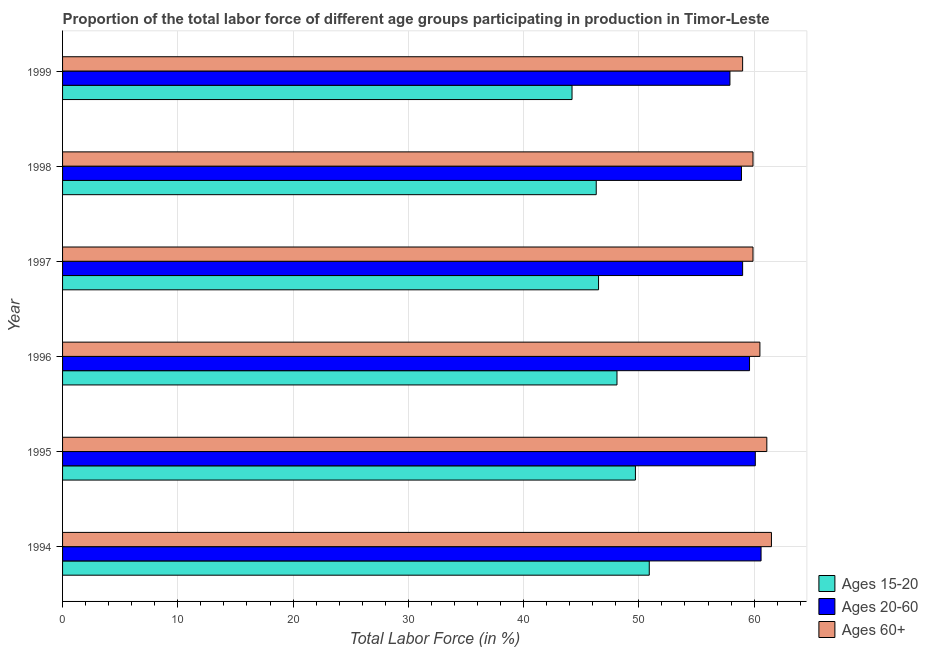Are the number of bars per tick equal to the number of legend labels?
Keep it short and to the point. Yes. Are the number of bars on each tick of the Y-axis equal?
Give a very brief answer. Yes. How many bars are there on the 3rd tick from the bottom?
Offer a terse response. 3. What is the label of the 5th group of bars from the top?
Ensure brevity in your answer.  1995. In how many cases, is the number of bars for a given year not equal to the number of legend labels?
Ensure brevity in your answer.  0. What is the percentage of labor force above age 60 in 1998?
Ensure brevity in your answer.  59.9. Across all years, what is the maximum percentage of labor force within the age group 15-20?
Ensure brevity in your answer.  50.9. Across all years, what is the minimum percentage of labor force within the age group 15-20?
Give a very brief answer. 44.2. In which year was the percentage of labor force above age 60 maximum?
Offer a terse response. 1994. In which year was the percentage of labor force above age 60 minimum?
Provide a short and direct response. 1999. What is the total percentage of labor force within the age group 15-20 in the graph?
Offer a very short reply. 285.7. What is the difference between the percentage of labor force above age 60 in 1994 and the percentage of labor force within the age group 20-60 in 1999?
Offer a terse response. 3.6. What is the average percentage of labor force within the age group 15-20 per year?
Offer a very short reply. 47.62. In how many years, is the percentage of labor force above age 60 greater than 2 %?
Your answer should be very brief. 6. Is the difference between the percentage of labor force within the age group 20-60 in 1994 and 1999 greater than the difference between the percentage of labor force within the age group 15-20 in 1994 and 1999?
Ensure brevity in your answer.  No. What is the difference between the highest and the second highest percentage of labor force above age 60?
Your answer should be very brief. 0.4. What is the difference between the highest and the lowest percentage of labor force above age 60?
Your answer should be compact. 2.5. What does the 2nd bar from the top in 1995 represents?
Provide a succinct answer. Ages 20-60. What does the 3rd bar from the bottom in 1997 represents?
Offer a very short reply. Ages 60+. Does the graph contain grids?
Offer a very short reply. Yes. Where does the legend appear in the graph?
Offer a very short reply. Bottom right. How many legend labels are there?
Provide a succinct answer. 3. How are the legend labels stacked?
Keep it short and to the point. Vertical. What is the title of the graph?
Offer a very short reply. Proportion of the total labor force of different age groups participating in production in Timor-Leste. Does "Male employers" appear as one of the legend labels in the graph?
Make the answer very short. No. What is the label or title of the X-axis?
Offer a very short reply. Total Labor Force (in %). What is the label or title of the Y-axis?
Make the answer very short. Year. What is the Total Labor Force (in %) in Ages 15-20 in 1994?
Offer a terse response. 50.9. What is the Total Labor Force (in %) of Ages 20-60 in 1994?
Provide a short and direct response. 60.6. What is the Total Labor Force (in %) of Ages 60+ in 1994?
Your response must be concise. 61.5. What is the Total Labor Force (in %) in Ages 15-20 in 1995?
Offer a very short reply. 49.7. What is the Total Labor Force (in %) of Ages 20-60 in 1995?
Provide a succinct answer. 60.1. What is the Total Labor Force (in %) in Ages 60+ in 1995?
Your answer should be very brief. 61.1. What is the Total Labor Force (in %) of Ages 15-20 in 1996?
Provide a short and direct response. 48.1. What is the Total Labor Force (in %) of Ages 20-60 in 1996?
Offer a terse response. 59.6. What is the Total Labor Force (in %) of Ages 60+ in 1996?
Your response must be concise. 60.5. What is the Total Labor Force (in %) in Ages 15-20 in 1997?
Your answer should be compact. 46.5. What is the Total Labor Force (in %) in Ages 20-60 in 1997?
Ensure brevity in your answer.  59. What is the Total Labor Force (in %) in Ages 60+ in 1997?
Your answer should be compact. 59.9. What is the Total Labor Force (in %) in Ages 15-20 in 1998?
Your response must be concise. 46.3. What is the Total Labor Force (in %) in Ages 20-60 in 1998?
Keep it short and to the point. 58.9. What is the Total Labor Force (in %) in Ages 60+ in 1998?
Provide a short and direct response. 59.9. What is the Total Labor Force (in %) of Ages 15-20 in 1999?
Offer a terse response. 44.2. What is the Total Labor Force (in %) of Ages 20-60 in 1999?
Provide a short and direct response. 57.9. What is the Total Labor Force (in %) of Ages 60+ in 1999?
Give a very brief answer. 59. Across all years, what is the maximum Total Labor Force (in %) in Ages 15-20?
Provide a succinct answer. 50.9. Across all years, what is the maximum Total Labor Force (in %) of Ages 20-60?
Give a very brief answer. 60.6. Across all years, what is the maximum Total Labor Force (in %) in Ages 60+?
Give a very brief answer. 61.5. Across all years, what is the minimum Total Labor Force (in %) of Ages 15-20?
Provide a short and direct response. 44.2. Across all years, what is the minimum Total Labor Force (in %) of Ages 20-60?
Offer a very short reply. 57.9. Across all years, what is the minimum Total Labor Force (in %) of Ages 60+?
Your answer should be very brief. 59. What is the total Total Labor Force (in %) in Ages 15-20 in the graph?
Provide a succinct answer. 285.7. What is the total Total Labor Force (in %) in Ages 20-60 in the graph?
Your answer should be very brief. 356.1. What is the total Total Labor Force (in %) of Ages 60+ in the graph?
Offer a terse response. 361.9. What is the difference between the Total Labor Force (in %) in Ages 20-60 in 1994 and that in 1995?
Your answer should be very brief. 0.5. What is the difference between the Total Labor Force (in %) in Ages 60+ in 1994 and that in 1995?
Ensure brevity in your answer.  0.4. What is the difference between the Total Labor Force (in %) of Ages 15-20 in 1994 and that in 1996?
Make the answer very short. 2.8. What is the difference between the Total Labor Force (in %) of Ages 60+ in 1994 and that in 1996?
Ensure brevity in your answer.  1. What is the difference between the Total Labor Force (in %) in Ages 15-20 in 1994 and that in 1997?
Your response must be concise. 4.4. What is the difference between the Total Labor Force (in %) in Ages 20-60 in 1994 and that in 1997?
Provide a succinct answer. 1.6. What is the difference between the Total Labor Force (in %) of Ages 15-20 in 1994 and that in 1998?
Make the answer very short. 4.6. What is the difference between the Total Labor Force (in %) in Ages 60+ in 1994 and that in 1999?
Offer a terse response. 2.5. What is the difference between the Total Labor Force (in %) in Ages 60+ in 1995 and that in 1996?
Give a very brief answer. 0.6. What is the difference between the Total Labor Force (in %) of Ages 15-20 in 1995 and that in 1997?
Keep it short and to the point. 3.2. What is the difference between the Total Labor Force (in %) in Ages 20-60 in 1995 and that in 1997?
Make the answer very short. 1.1. What is the difference between the Total Labor Force (in %) of Ages 60+ in 1995 and that in 1997?
Your answer should be very brief. 1.2. What is the difference between the Total Labor Force (in %) in Ages 20-60 in 1995 and that in 1999?
Offer a terse response. 2.2. What is the difference between the Total Labor Force (in %) in Ages 20-60 in 1996 and that in 1997?
Provide a succinct answer. 0.6. What is the difference between the Total Labor Force (in %) in Ages 60+ in 1996 and that in 1997?
Your response must be concise. 0.6. What is the difference between the Total Labor Force (in %) in Ages 15-20 in 1996 and that in 1998?
Offer a terse response. 1.8. What is the difference between the Total Labor Force (in %) of Ages 20-60 in 1996 and that in 1998?
Offer a terse response. 0.7. What is the difference between the Total Labor Force (in %) of Ages 20-60 in 1996 and that in 1999?
Make the answer very short. 1.7. What is the difference between the Total Labor Force (in %) of Ages 15-20 in 1997 and that in 1998?
Keep it short and to the point. 0.2. What is the difference between the Total Labor Force (in %) in Ages 60+ in 1997 and that in 1998?
Offer a terse response. 0. What is the difference between the Total Labor Force (in %) of Ages 15-20 in 1997 and that in 1999?
Make the answer very short. 2.3. What is the difference between the Total Labor Force (in %) in Ages 60+ in 1997 and that in 1999?
Your answer should be very brief. 0.9. What is the difference between the Total Labor Force (in %) of Ages 60+ in 1998 and that in 1999?
Provide a succinct answer. 0.9. What is the difference between the Total Labor Force (in %) of Ages 15-20 in 1994 and the Total Labor Force (in %) of Ages 20-60 in 1996?
Ensure brevity in your answer.  -8.7. What is the difference between the Total Labor Force (in %) of Ages 20-60 in 1994 and the Total Labor Force (in %) of Ages 60+ in 1996?
Ensure brevity in your answer.  0.1. What is the difference between the Total Labor Force (in %) in Ages 15-20 in 1994 and the Total Labor Force (in %) in Ages 60+ in 1997?
Give a very brief answer. -9. What is the difference between the Total Labor Force (in %) in Ages 20-60 in 1994 and the Total Labor Force (in %) in Ages 60+ in 1998?
Make the answer very short. 0.7. What is the difference between the Total Labor Force (in %) in Ages 15-20 in 1994 and the Total Labor Force (in %) in Ages 20-60 in 1999?
Your response must be concise. -7. What is the difference between the Total Labor Force (in %) in Ages 15-20 in 1995 and the Total Labor Force (in %) in Ages 20-60 in 1996?
Your response must be concise. -9.9. What is the difference between the Total Labor Force (in %) in Ages 15-20 in 1995 and the Total Labor Force (in %) in Ages 60+ in 1996?
Offer a terse response. -10.8. What is the difference between the Total Labor Force (in %) of Ages 20-60 in 1995 and the Total Labor Force (in %) of Ages 60+ in 1996?
Make the answer very short. -0.4. What is the difference between the Total Labor Force (in %) of Ages 15-20 in 1995 and the Total Labor Force (in %) of Ages 20-60 in 1997?
Your answer should be compact. -9.3. What is the difference between the Total Labor Force (in %) in Ages 15-20 in 1995 and the Total Labor Force (in %) in Ages 60+ in 1997?
Ensure brevity in your answer.  -10.2. What is the difference between the Total Labor Force (in %) in Ages 15-20 in 1995 and the Total Labor Force (in %) in Ages 20-60 in 1998?
Provide a short and direct response. -9.2. What is the difference between the Total Labor Force (in %) in Ages 15-20 in 1995 and the Total Labor Force (in %) in Ages 20-60 in 1999?
Your response must be concise. -8.2. What is the difference between the Total Labor Force (in %) of Ages 20-60 in 1995 and the Total Labor Force (in %) of Ages 60+ in 1999?
Provide a succinct answer. 1.1. What is the difference between the Total Labor Force (in %) in Ages 15-20 in 1996 and the Total Labor Force (in %) in Ages 60+ in 1997?
Give a very brief answer. -11.8. What is the difference between the Total Labor Force (in %) of Ages 15-20 in 1996 and the Total Labor Force (in %) of Ages 20-60 in 1998?
Ensure brevity in your answer.  -10.8. What is the difference between the Total Labor Force (in %) in Ages 20-60 in 1996 and the Total Labor Force (in %) in Ages 60+ in 1998?
Keep it short and to the point. -0.3. What is the difference between the Total Labor Force (in %) in Ages 15-20 in 1996 and the Total Labor Force (in %) in Ages 60+ in 1999?
Your answer should be compact. -10.9. What is the difference between the Total Labor Force (in %) of Ages 15-20 in 1997 and the Total Labor Force (in %) of Ages 20-60 in 1999?
Give a very brief answer. -11.4. What is the difference between the Total Labor Force (in %) of Ages 15-20 in 1998 and the Total Labor Force (in %) of Ages 20-60 in 1999?
Offer a terse response. -11.6. What is the average Total Labor Force (in %) in Ages 15-20 per year?
Provide a short and direct response. 47.62. What is the average Total Labor Force (in %) of Ages 20-60 per year?
Offer a very short reply. 59.35. What is the average Total Labor Force (in %) of Ages 60+ per year?
Your response must be concise. 60.32. In the year 1995, what is the difference between the Total Labor Force (in %) in Ages 15-20 and Total Labor Force (in %) in Ages 20-60?
Provide a succinct answer. -10.4. In the year 1995, what is the difference between the Total Labor Force (in %) in Ages 15-20 and Total Labor Force (in %) in Ages 60+?
Provide a succinct answer. -11.4. In the year 1995, what is the difference between the Total Labor Force (in %) in Ages 20-60 and Total Labor Force (in %) in Ages 60+?
Your response must be concise. -1. In the year 1996, what is the difference between the Total Labor Force (in %) in Ages 15-20 and Total Labor Force (in %) in Ages 20-60?
Your answer should be very brief. -11.5. In the year 1996, what is the difference between the Total Labor Force (in %) of Ages 15-20 and Total Labor Force (in %) of Ages 60+?
Your answer should be compact. -12.4. In the year 1997, what is the difference between the Total Labor Force (in %) in Ages 15-20 and Total Labor Force (in %) in Ages 60+?
Offer a terse response. -13.4. In the year 1997, what is the difference between the Total Labor Force (in %) in Ages 20-60 and Total Labor Force (in %) in Ages 60+?
Provide a short and direct response. -0.9. In the year 1998, what is the difference between the Total Labor Force (in %) of Ages 15-20 and Total Labor Force (in %) of Ages 60+?
Offer a very short reply. -13.6. In the year 1998, what is the difference between the Total Labor Force (in %) in Ages 20-60 and Total Labor Force (in %) in Ages 60+?
Keep it short and to the point. -1. In the year 1999, what is the difference between the Total Labor Force (in %) in Ages 15-20 and Total Labor Force (in %) in Ages 20-60?
Your answer should be compact. -13.7. In the year 1999, what is the difference between the Total Labor Force (in %) in Ages 15-20 and Total Labor Force (in %) in Ages 60+?
Ensure brevity in your answer.  -14.8. In the year 1999, what is the difference between the Total Labor Force (in %) of Ages 20-60 and Total Labor Force (in %) of Ages 60+?
Your answer should be very brief. -1.1. What is the ratio of the Total Labor Force (in %) in Ages 15-20 in 1994 to that in 1995?
Your answer should be very brief. 1.02. What is the ratio of the Total Labor Force (in %) in Ages 20-60 in 1994 to that in 1995?
Your response must be concise. 1.01. What is the ratio of the Total Labor Force (in %) in Ages 60+ in 1994 to that in 1995?
Offer a terse response. 1.01. What is the ratio of the Total Labor Force (in %) in Ages 15-20 in 1994 to that in 1996?
Offer a terse response. 1.06. What is the ratio of the Total Labor Force (in %) of Ages 20-60 in 1994 to that in 1996?
Your answer should be compact. 1.02. What is the ratio of the Total Labor Force (in %) of Ages 60+ in 1994 to that in 1996?
Your response must be concise. 1.02. What is the ratio of the Total Labor Force (in %) in Ages 15-20 in 1994 to that in 1997?
Your answer should be very brief. 1.09. What is the ratio of the Total Labor Force (in %) of Ages 20-60 in 1994 to that in 1997?
Offer a very short reply. 1.03. What is the ratio of the Total Labor Force (in %) of Ages 60+ in 1994 to that in 1997?
Ensure brevity in your answer.  1.03. What is the ratio of the Total Labor Force (in %) in Ages 15-20 in 1994 to that in 1998?
Offer a terse response. 1.1. What is the ratio of the Total Labor Force (in %) in Ages 20-60 in 1994 to that in 1998?
Ensure brevity in your answer.  1.03. What is the ratio of the Total Labor Force (in %) of Ages 60+ in 1994 to that in 1998?
Provide a short and direct response. 1.03. What is the ratio of the Total Labor Force (in %) of Ages 15-20 in 1994 to that in 1999?
Your response must be concise. 1.15. What is the ratio of the Total Labor Force (in %) in Ages 20-60 in 1994 to that in 1999?
Make the answer very short. 1.05. What is the ratio of the Total Labor Force (in %) in Ages 60+ in 1994 to that in 1999?
Your answer should be compact. 1.04. What is the ratio of the Total Labor Force (in %) of Ages 20-60 in 1995 to that in 1996?
Make the answer very short. 1.01. What is the ratio of the Total Labor Force (in %) in Ages 60+ in 1995 to that in 1996?
Your answer should be compact. 1.01. What is the ratio of the Total Labor Force (in %) in Ages 15-20 in 1995 to that in 1997?
Your response must be concise. 1.07. What is the ratio of the Total Labor Force (in %) in Ages 20-60 in 1995 to that in 1997?
Provide a succinct answer. 1.02. What is the ratio of the Total Labor Force (in %) in Ages 15-20 in 1995 to that in 1998?
Make the answer very short. 1.07. What is the ratio of the Total Labor Force (in %) in Ages 20-60 in 1995 to that in 1998?
Offer a very short reply. 1.02. What is the ratio of the Total Labor Force (in %) in Ages 60+ in 1995 to that in 1998?
Offer a terse response. 1.02. What is the ratio of the Total Labor Force (in %) of Ages 15-20 in 1995 to that in 1999?
Keep it short and to the point. 1.12. What is the ratio of the Total Labor Force (in %) of Ages 20-60 in 1995 to that in 1999?
Your answer should be compact. 1.04. What is the ratio of the Total Labor Force (in %) of Ages 60+ in 1995 to that in 1999?
Offer a terse response. 1.04. What is the ratio of the Total Labor Force (in %) of Ages 15-20 in 1996 to that in 1997?
Your answer should be compact. 1.03. What is the ratio of the Total Labor Force (in %) in Ages 20-60 in 1996 to that in 1997?
Offer a terse response. 1.01. What is the ratio of the Total Labor Force (in %) of Ages 60+ in 1996 to that in 1997?
Offer a very short reply. 1.01. What is the ratio of the Total Labor Force (in %) in Ages 15-20 in 1996 to that in 1998?
Provide a short and direct response. 1.04. What is the ratio of the Total Labor Force (in %) in Ages 20-60 in 1996 to that in 1998?
Offer a very short reply. 1.01. What is the ratio of the Total Labor Force (in %) in Ages 15-20 in 1996 to that in 1999?
Provide a succinct answer. 1.09. What is the ratio of the Total Labor Force (in %) of Ages 20-60 in 1996 to that in 1999?
Offer a terse response. 1.03. What is the ratio of the Total Labor Force (in %) of Ages 60+ in 1996 to that in 1999?
Offer a terse response. 1.03. What is the ratio of the Total Labor Force (in %) in Ages 20-60 in 1997 to that in 1998?
Offer a terse response. 1. What is the ratio of the Total Labor Force (in %) in Ages 15-20 in 1997 to that in 1999?
Provide a short and direct response. 1.05. What is the ratio of the Total Labor Force (in %) in Ages 20-60 in 1997 to that in 1999?
Ensure brevity in your answer.  1.02. What is the ratio of the Total Labor Force (in %) in Ages 60+ in 1997 to that in 1999?
Offer a very short reply. 1.02. What is the ratio of the Total Labor Force (in %) of Ages 15-20 in 1998 to that in 1999?
Provide a succinct answer. 1.05. What is the ratio of the Total Labor Force (in %) in Ages 20-60 in 1998 to that in 1999?
Offer a terse response. 1.02. What is the ratio of the Total Labor Force (in %) in Ages 60+ in 1998 to that in 1999?
Keep it short and to the point. 1.02. What is the difference between the highest and the second highest Total Labor Force (in %) of Ages 15-20?
Your response must be concise. 1.2. What is the difference between the highest and the lowest Total Labor Force (in %) in Ages 15-20?
Your answer should be very brief. 6.7. What is the difference between the highest and the lowest Total Labor Force (in %) in Ages 20-60?
Make the answer very short. 2.7. What is the difference between the highest and the lowest Total Labor Force (in %) of Ages 60+?
Make the answer very short. 2.5. 